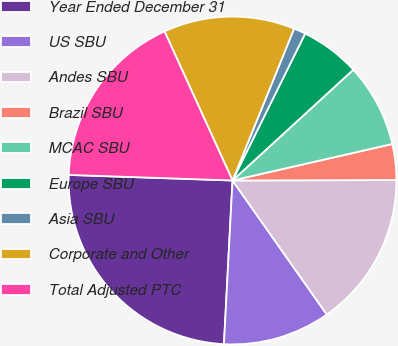Convert chart. <chart><loc_0><loc_0><loc_500><loc_500><pie_chart><fcel>Year Ended December 31<fcel>US SBU<fcel>Andes SBU<fcel>Brazil SBU<fcel>MCAC SBU<fcel>Europe SBU<fcel>Asia SBU<fcel>Corporate and Other<fcel>Total Adjusted PTC<nl><fcel>24.71%<fcel>10.59%<fcel>15.29%<fcel>3.53%<fcel>8.24%<fcel>5.88%<fcel>1.18%<fcel>12.94%<fcel>17.65%<nl></chart> 